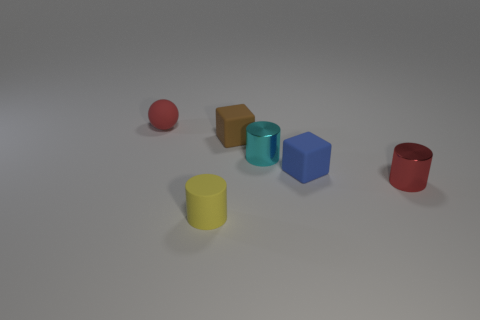Add 1 rubber blocks. How many objects exist? 7 Subtract all cubes. How many objects are left? 4 Add 1 cyan metallic objects. How many cyan metallic objects exist? 2 Subtract 1 yellow cylinders. How many objects are left? 5 Subtract all small cyan metal objects. Subtract all gray matte cylinders. How many objects are left? 5 Add 6 metallic cylinders. How many metallic cylinders are left? 8 